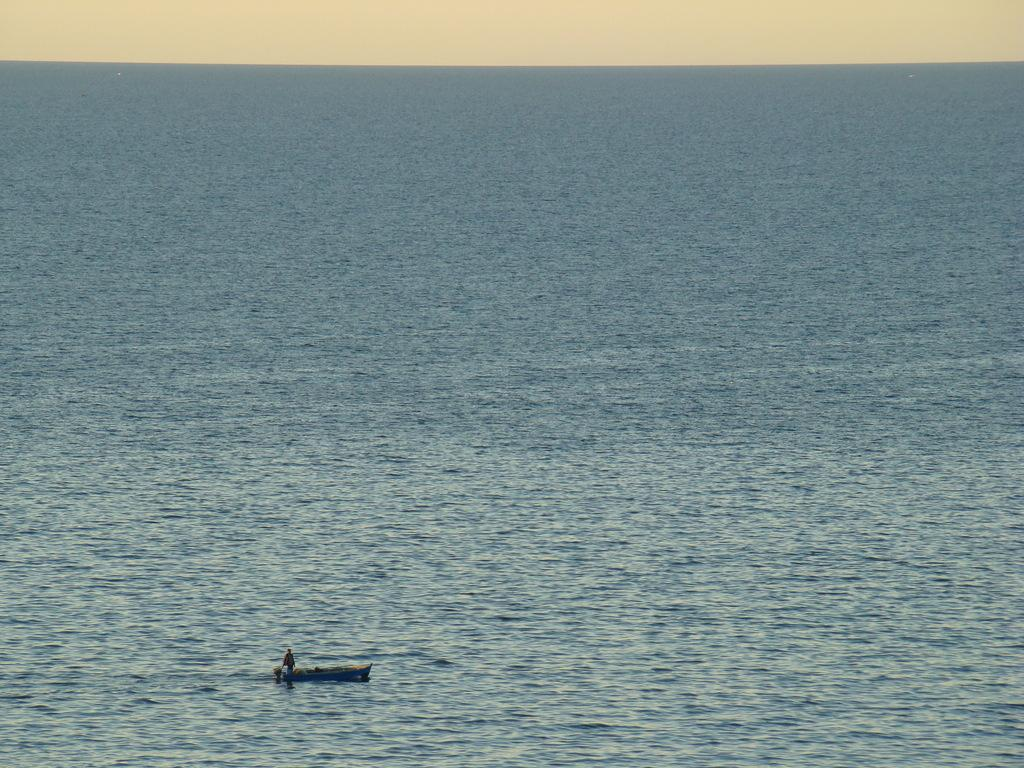What is the main subject of the image? The main subject of the image is a boat. Is there anyone on the boat? Yes, there is a person on the boat. Where is the boat located? The boat is on the sea. What is the weight of the church near the boat in the image? There is no church present in the image, so it is not possible to determine its weight. 